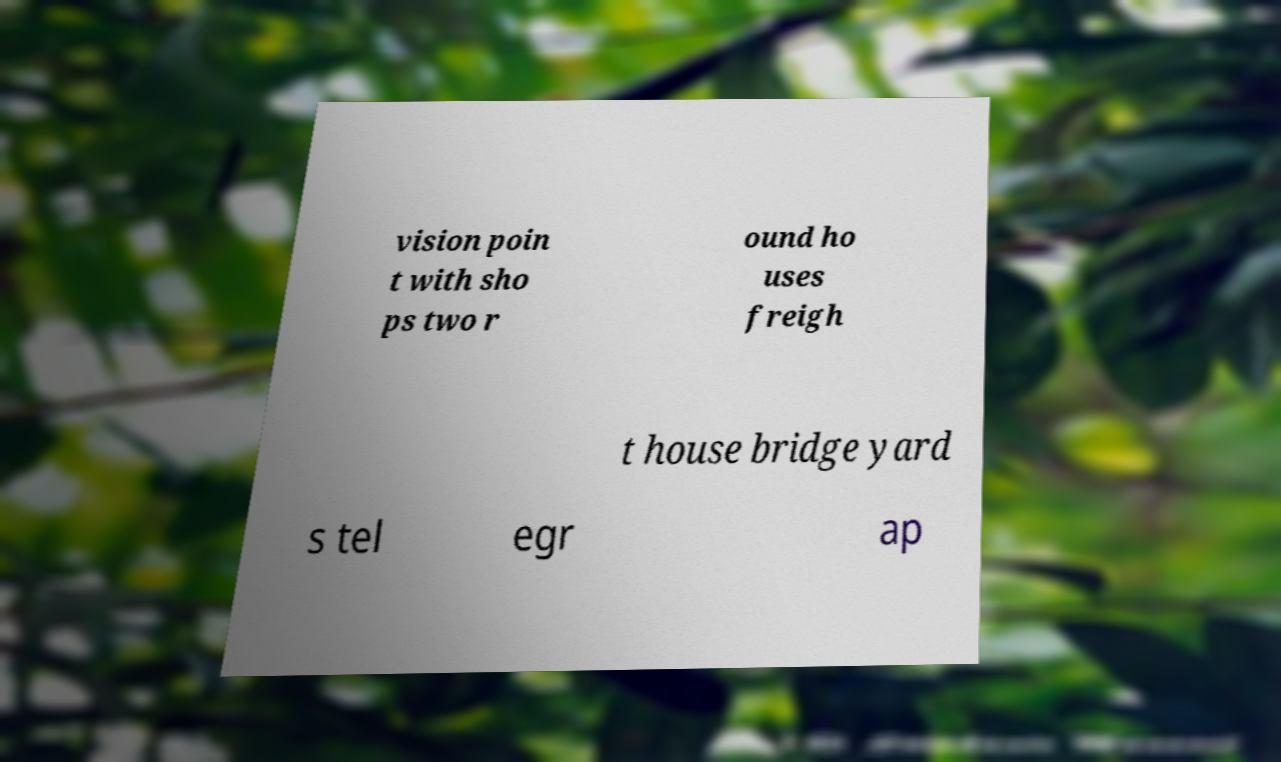Could you extract and type out the text from this image? vision poin t with sho ps two r ound ho uses freigh t house bridge yard s tel egr ap 